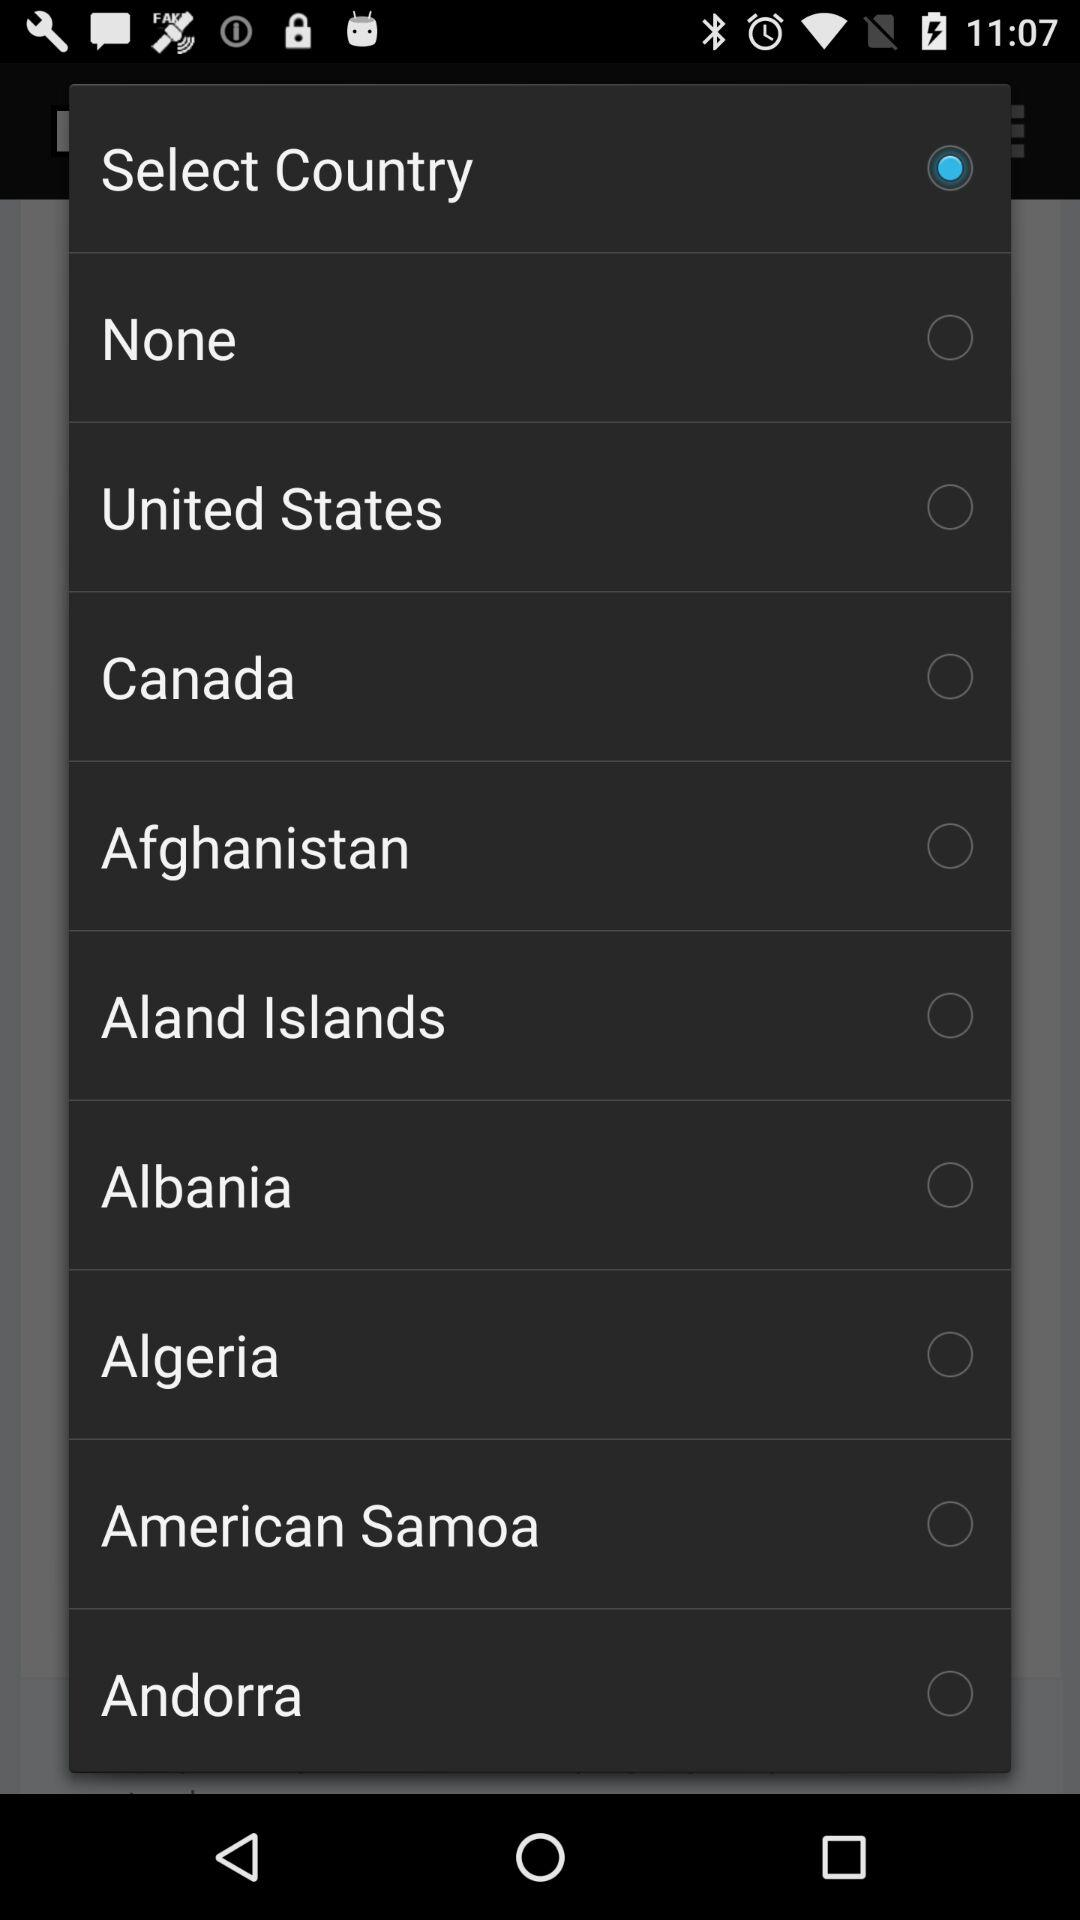Is "Albania" selected or not? It is "not selected". 